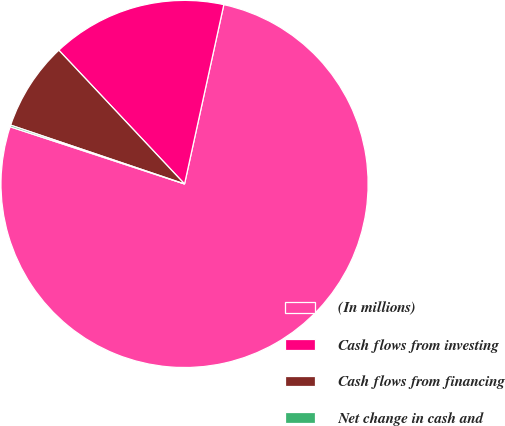Convert chart to OTSL. <chart><loc_0><loc_0><loc_500><loc_500><pie_chart><fcel>(In millions)<fcel>Cash flows from investing<fcel>Cash flows from financing<fcel>Net change in cash and<nl><fcel>76.61%<fcel>15.44%<fcel>7.8%<fcel>0.15%<nl></chart> 